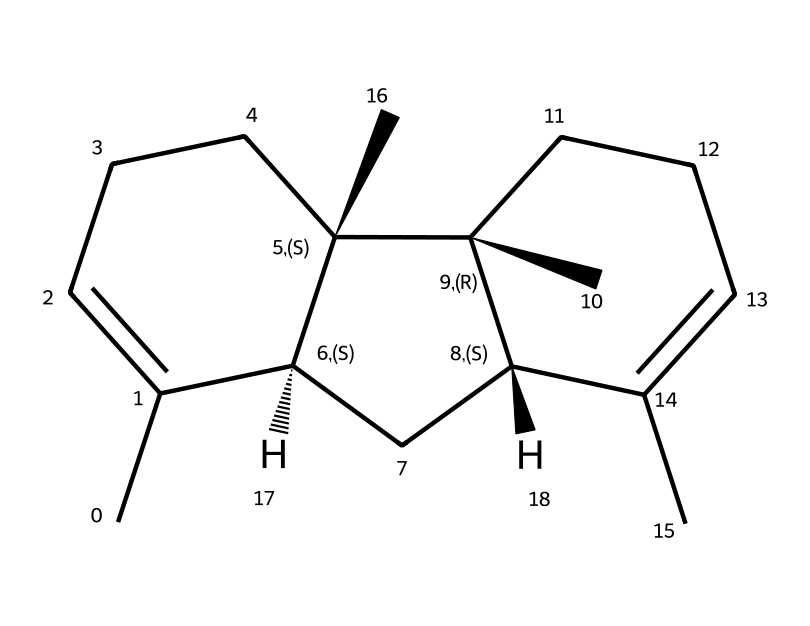What is the chemical name of the structure represented? The SMILES notation decodes to caryophyllene, a well-known terpene found in black pepper and cannabis.
Answer: caryophyllene How many carbon atoms are present in this molecule? Counting the carbon atoms in the structural representation shows there are 15 carbon atoms total, which is standard for caryophyllene.
Answer: 15 How many double bonds are present in the molecule? By analyzing the structure, it is evident that there are two double bonds present in the carbon chain.
Answer: 2 What is the significance of the chiral centers in this molecule? The two chiral centers in caryophyllene may lead to different stereoisomers, potentially affecting its aroma and biological properties.
Answer: stereoisomers Which functional group is prominent in caryophyllene? This structure primarily has a hydrocarbon backbone with a double bond, characteristic of terpenes, and lacks other functional groups, thereby making it an alkene.
Answer: alkene What distinguishes caryophyllene from other terpenes? Caryophyllene is distinct due to its unique cyclohexene structure and its ability to interact with cannabinoid receptors in the body, which is not common among all terpenes.
Answer: cannabinoid interaction What type of aroma is typically associated with caryophyllene? Caryophyllene is known for its spicy, peppery aroma, which is characteristic of its occurrence in black pepper.
Answer: spicy aroma 